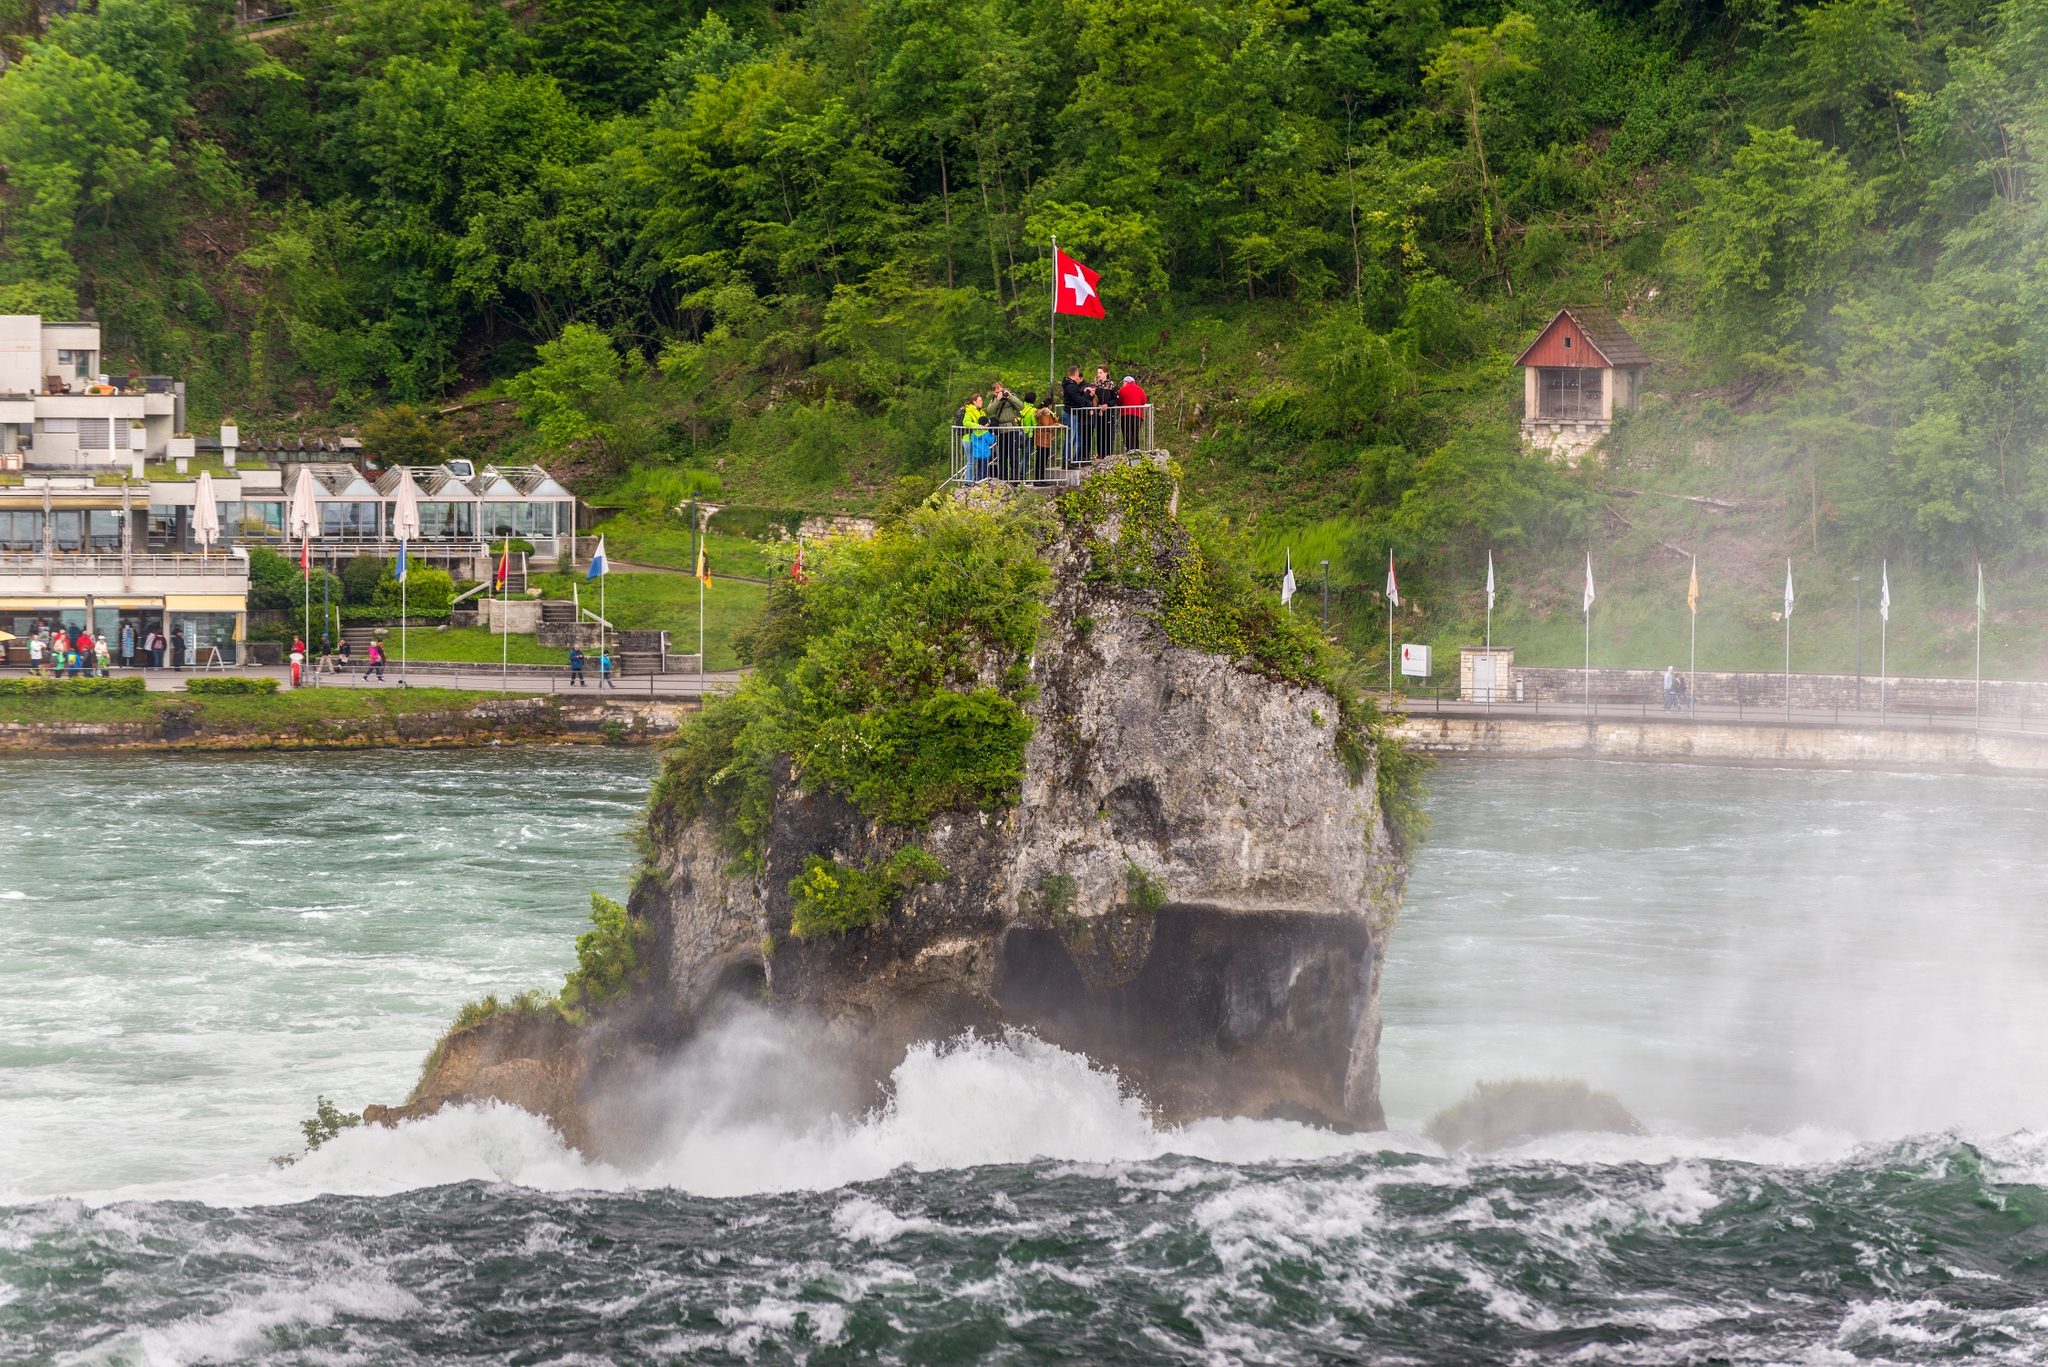Can you explain the significance of the Swiss flag on that rock? The Swiss flag displayed on the rock formation is a patriotic emblem, symbolically representing Switzerland's pride in its natural heritage. This flag placement at such a prominent natural site serves to signify ownership and pride, making it a point of national identity that resonates with both locals and visitors. 